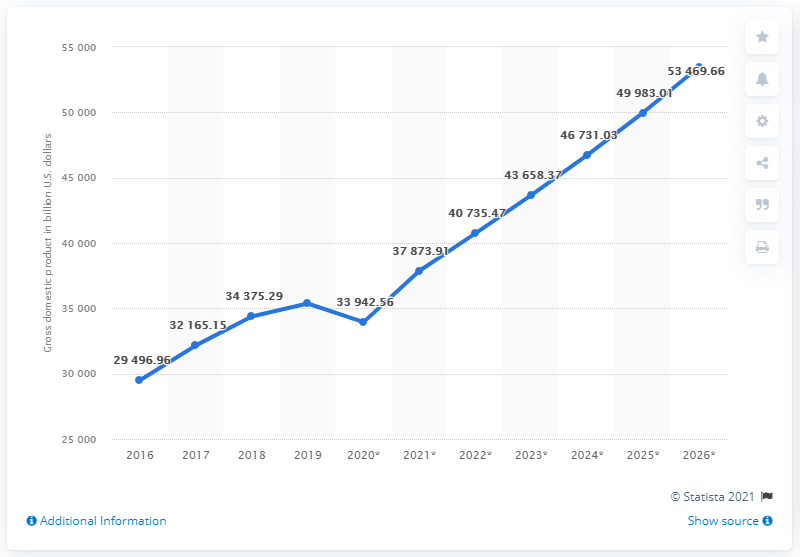List a handful of essential elements in this visual. In 2019, the gross domestic product of emerging market and developing economies was 35,370.68. 